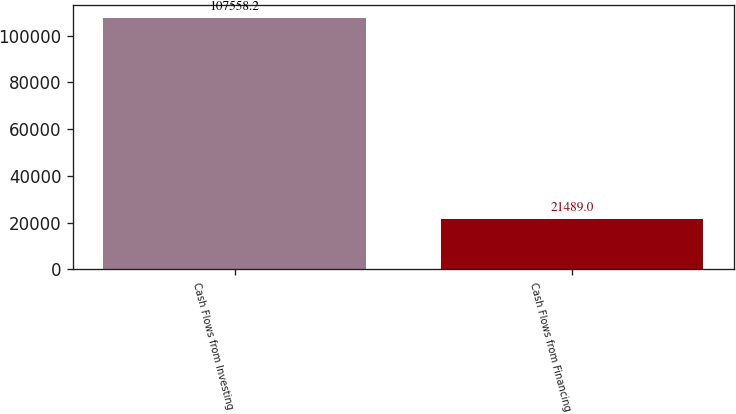Convert chart. <chart><loc_0><loc_0><loc_500><loc_500><bar_chart><fcel>Cash Flows from Investing<fcel>Cash Flows from Financing<nl><fcel>107558<fcel>21489<nl></chart> 